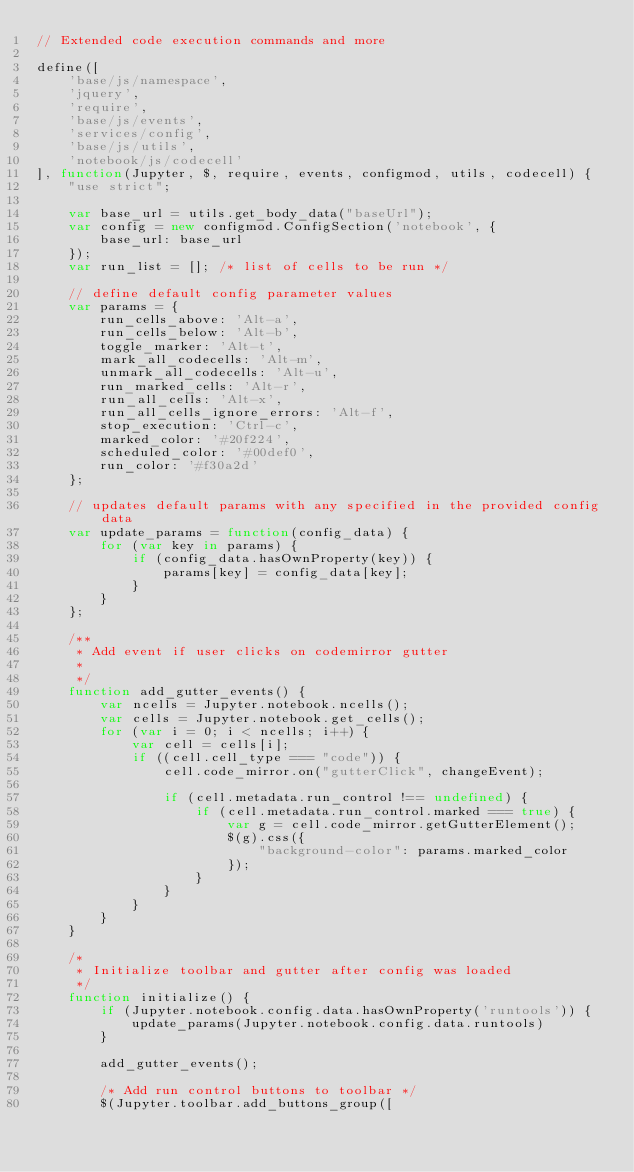<code> <loc_0><loc_0><loc_500><loc_500><_JavaScript_>// Extended code execution commands and more

define([
    'base/js/namespace',
    'jquery',
    'require',
    'base/js/events',
    'services/config',
    'base/js/utils',
    'notebook/js/codecell'
], function(Jupyter, $, require, events, configmod, utils, codecell) {
    "use strict";

    var base_url = utils.get_body_data("baseUrl");
    var config = new configmod.ConfigSection('notebook', {
        base_url: base_url
    });
    var run_list = []; /* list of cells to be run */

    // define default config parameter values
    var params = {
        run_cells_above: 'Alt-a',
        run_cells_below: 'Alt-b',
        toggle_marker: 'Alt-t',
        mark_all_codecells: 'Alt-m',
        unmark_all_codecells: 'Alt-u',
        run_marked_cells: 'Alt-r',
        run_all_cells: 'Alt-x',
        run_all_cells_ignore_errors: 'Alt-f',
        stop_execution: 'Ctrl-c',
        marked_color: '#20f224',
        scheduled_color: '#00def0',
        run_color: '#f30a2d'
    };

    // updates default params with any specified in the provided config data
    var update_params = function(config_data) {
        for (var key in params) {
            if (config_data.hasOwnProperty(key)) {
                params[key] = config_data[key];
            }
        }
    };

    /**
     * Add event if user clicks on codemirror gutter
     *
     */
    function add_gutter_events() {
        var ncells = Jupyter.notebook.ncells();
        var cells = Jupyter.notebook.get_cells();
        for (var i = 0; i < ncells; i++) {
            var cell = cells[i];
            if ((cell.cell_type === "code")) {
                cell.code_mirror.on("gutterClick", changeEvent);

                if (cell.metadata.run_control !== undefined) {
                    if (cell.metadata.run_control.marked === true) {
                        var g = cell.code_mirror.getGutterElement();
                        $(g).css({
                            "background-color": params.marked_color
                        });
                    }
                }
            }
        }
    }

    /*
     * Initialize toolbar and gutter after config was loaded
     */
    function initialize() {
        if (Jupyter.notebook.config.data.hasOwnProperty('runtools')) {
            update_params(Jupyter.notebook.config.data.runtools)
        }

        add_gutter_events();

        /* Add run control buttons to toolbar */
        $(Jupyter.toolbar.add_buttons_group([</code> 